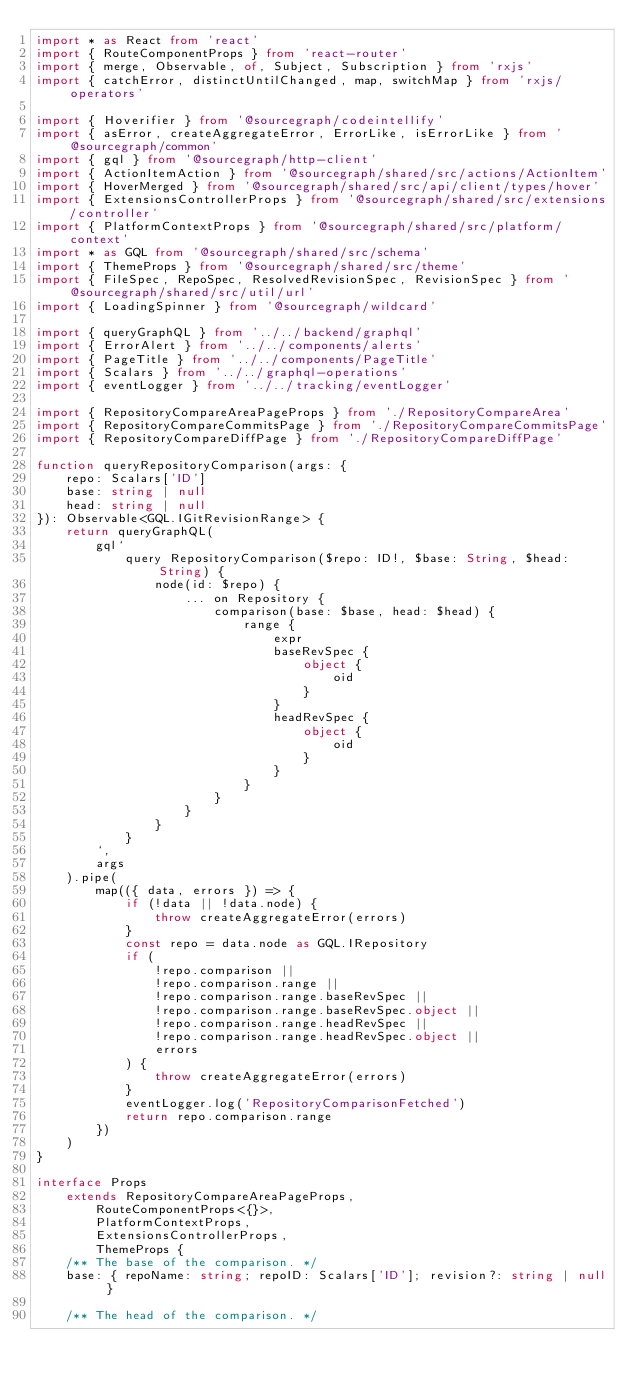Convert code to text. <code><loc_0><loc_0><loc_500><loc_500><_TypeScript_>import * as React from 'react'
import { RouteComponentProps } from 'react-router'
import { merge, Observable, of, Subject, Subscription } from 'rxjs'
import { catchError, distinctUntilChanged, map, switchMap } from 'rxjs/operators'

import { Hoverifier } from '@sourcegraph/codeintellify'
import { asError, createAggregateError, ErrorLike, isErrorLike } from '@sourcegraph/common'
import { gql } from '@sourcegraph/http-client'
import { ActionItemAction } from '@sourcegraph/shared/src/actions/ActionItem'
import { HoverMerged } from '@sourcegraph/shared/src/api/client/types/hover'
import { ExtensionsControllerProps } from '@sourcegraph/shared/src/extensions/controller'
import { PlatformContextProps } from '@sourcegraph/shared/src/platform/context'
import * as GQL from '@sourcegraph/shared/src/schema'
import { ThemeProps } from '@sourcegraph/shared/src/theme'
import { FileSpec, RepoSpec, ResolvedRevisionSpec, RevisionSpec } from '@sourcegraph/shared/src/util/url'
import { LoadingSpinner } from '@sourcegraph/wildcard'

import { queryGraphQL } from '../../backend/graphql'
import { ErrorAlert } from '../../components/alerts'
import { PageTitle } from '../../components/PageTitle'
import { Scalars } from '../../graphql-operations'
import { eventLogger } from '../../tracking/eventLogger'

import { RepositoryCompareAreaPageProps } from './RepositoryCompareArea'
import { RepositoryCompareCommitsPage } from './RepositoryCompareCommitsPage'
import { RepositoryCompareDiffPage } from './RepositoryCompareDiffPage'

function queryRepositoryComparison(args: {
    repo: Scalars['ID']
    base: string | null
    head: string | null
}): Observable<GQL.IGitRevisionRange> {
    return queryGraphQL(
        gql`
            query RepositoryComparison($repo: ID!, $base: String, $head: String) {
                node(id: $repo) {
                    ... on Repository {
                        comparison(base: $base, head: $head) {
                            range {
                                expr
                                baseRevSpec {
                                    object {
                                        oid
                                    }
                                }
                                headRevSpec {
                                    object {
                                        oid
                                    }
                                }
                            }
                        }
                    }
                }
            }
        `,
        args
    ).pipe(
        map(({ data, errors }) => {
            if (!data || !data.node) {
                throw createAggregateError(errors)
            }
            const repo = data.node as GQL.IRepository
            if (
                !repo.comparison ||
                !repo.comparison.range ||
                !repo.comparison.range.baseRevSpec ||
                !repo.comparison.range.baseRevSpec.object ||
                !repo.comparison.range.headRevSpec ||
                !repo.comparison.range.headRevSpec.object ||
                errors
            ) {
                throw createAggregateError(errors)
            }
            eventLogger.log('RepositoryComparisonFetched')
            return repo.comparison.range
        })
    )
}

interface Props
    extends RepositoryCompareAreaPageProps,
        RouteComponentProps<{}>,
        PlatformContextProps,
        ExtensionsControllerProps,
        ThemeProps {
    /** The base of the comparison. */
    base: { repoName: string; repoID: Scalars['ID']; revision?: string | null }

    /** The head of the comparison. */</code> 